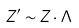<formula> <loc_0><loc_0><loc_500><loc_500>Z ^ { \prime } \sim Z \cdot \Lambda</formula> 